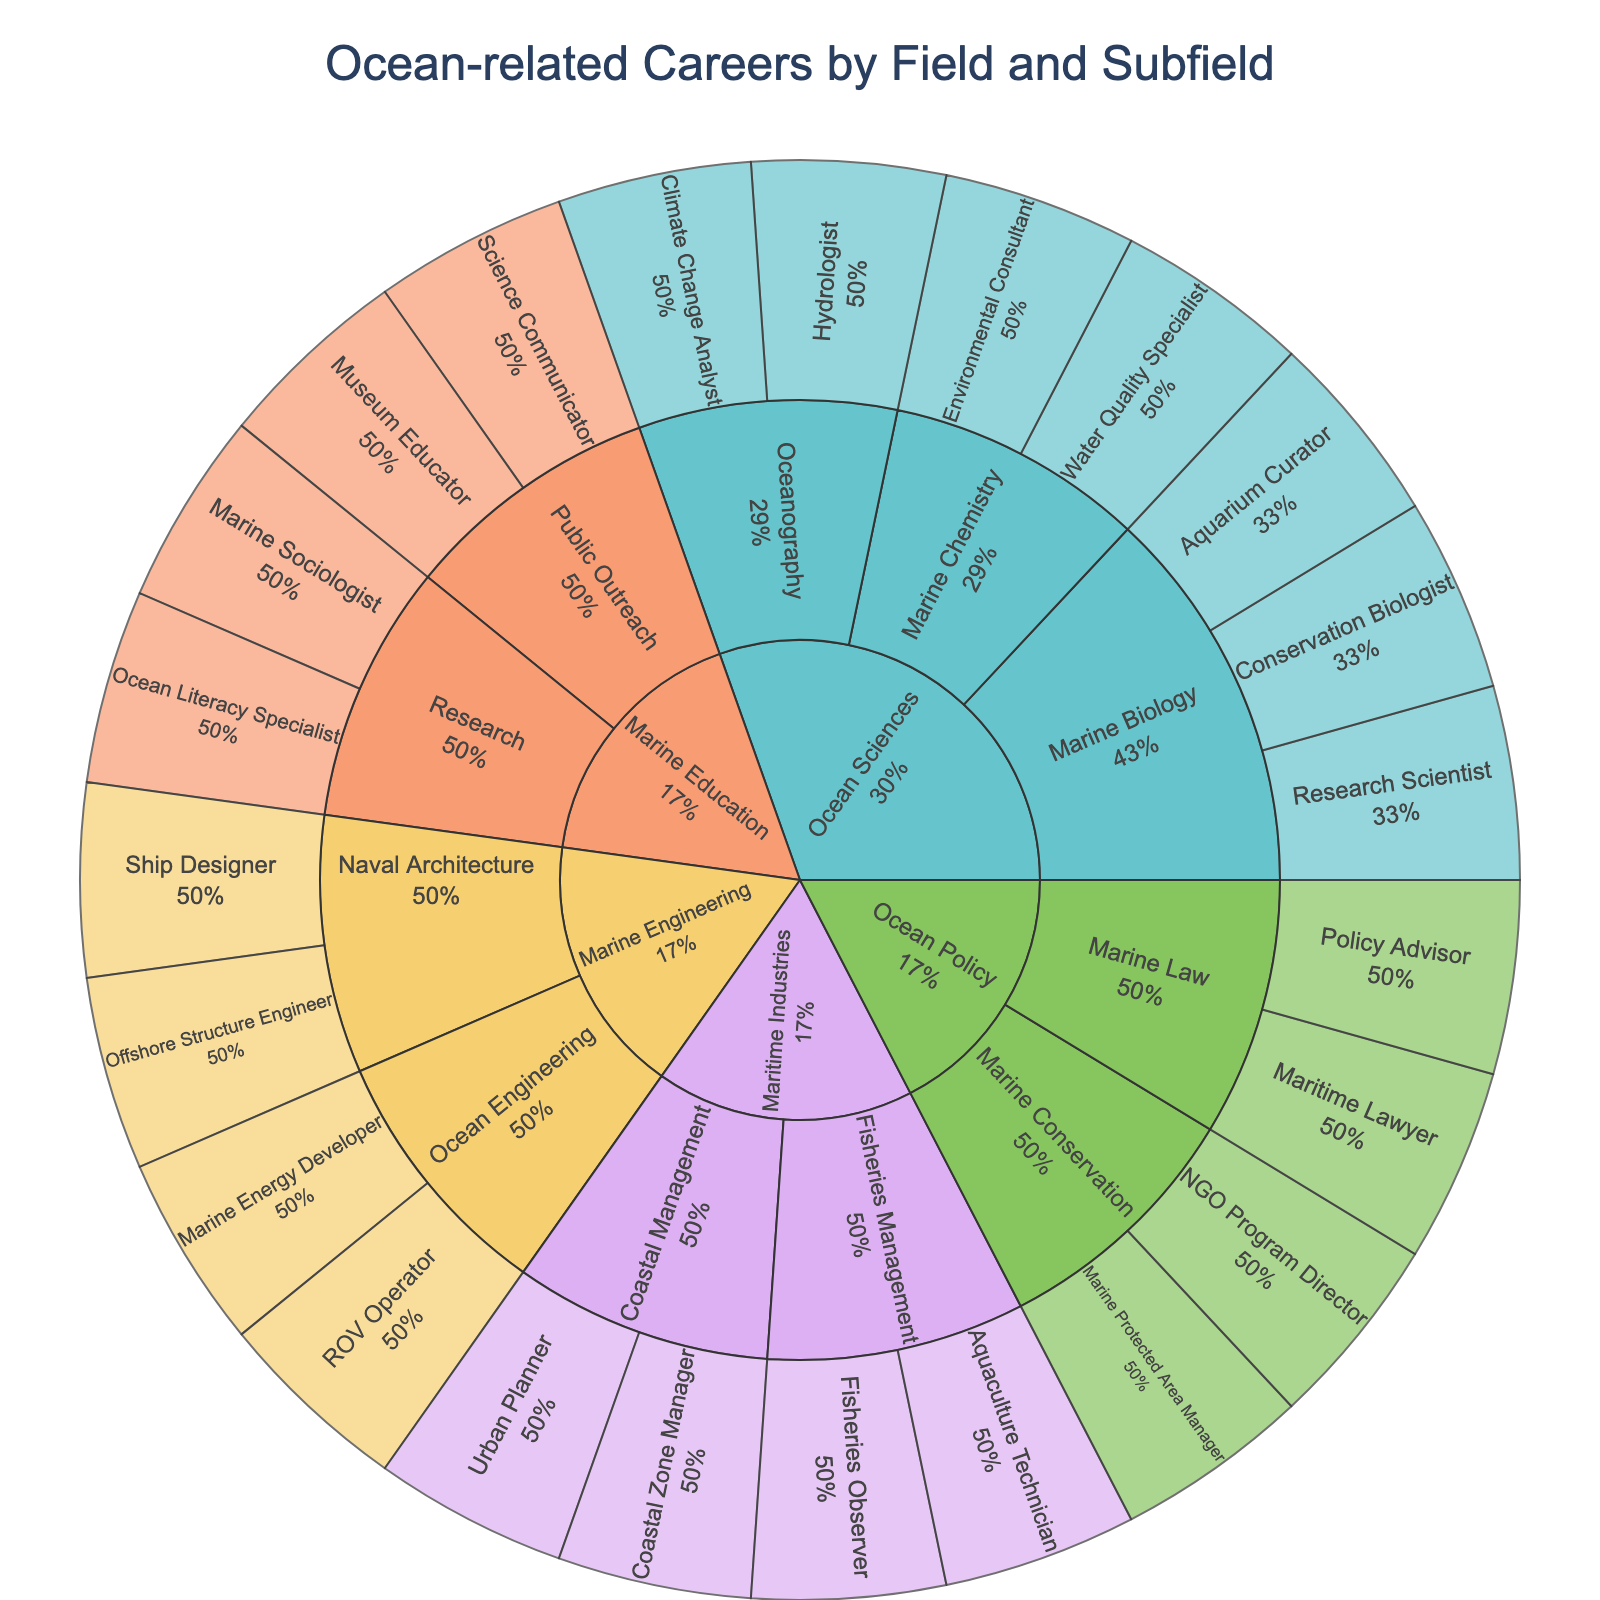what is the title of the sunburst plot? The title is displayed at the top of the figure. It provides a clear and concise description of what the figure represents.
Answer: Ocean-related Careers by Field and Subfield How many careers are listed under the Marine Biology subfield? The Marine Biology subfield appears as a section connecting to the Ocean Sciences field in the sunburst plot. Within this subfield, count the individual careers listed.
Answer: 3 Which subfield in the Ocean Sciences field has the largest proportion of careers? Look at the segments within the Ocean Sciences field and compare their sizes. The largest segment represents the subfield with the most careers.
Answer: Marine Biology Which career has the smallest proportion in the Maritime Industries field? Within the Maritime Industries field, identify the segment with the smallest area. This smaller segment represents the career with the least proportion.
Answer: Urban Planner Compare the number of careers between Marine Education and Ocean Policy. Which has more careers? Observe the number of segments representing careers in each of these fields. Count and compare them to determine which has more careers.
Answer: Marine Education What percentage of careers does the Fisheries Management subfield represent in the Maritime Industries field? Find the Fisheries Management subfield within the Maritime Industries field. The proportion of this subfield, relative to the Maritime Industries field, is typically displayed as a percentage inside the segment or on hover.
Answer: 50% How many subfields are under the Marine Engineering field? Look at the divisions under the Marine Engineering field and count the distinct subfields represented in the sunburst plot.
Answer: 2 What is the second most represented career in the Ocean Sciences field? Identify the career segments within the Ocean Sciences field and compare their sizes (proportions). The career with the second largest segment is the second most represented.
Answer: Hydrologist Which field contains the Marine Sociologist career? Locate the Marine Sociologist career in the sunburst plot and trace it back through the subfield to the main field it belongs to.
Answer: Marine Education Are there more careers in the Coastal Management subfield or the Marine Law subfield? Compare the number of career segments displayed in the Coastal Management subfield to those in the Marine Law subfield.
Answer: Coastal Management 